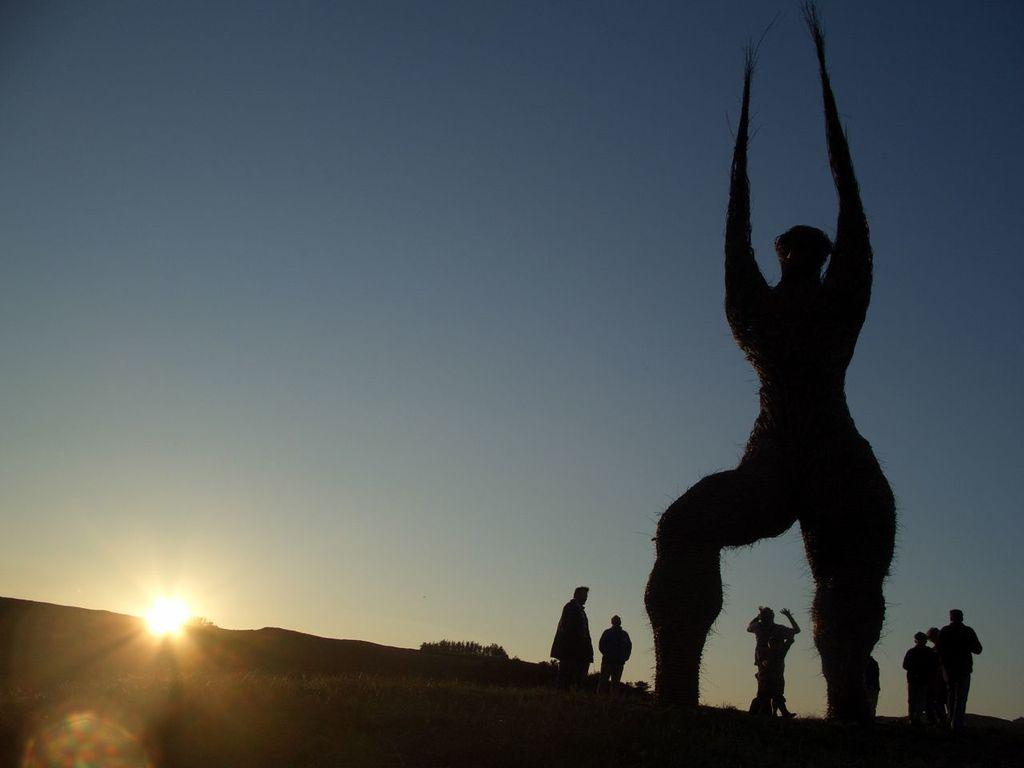How many people are in the image? There are persons standing in the image. What are the persons doing in the image? The persons are staring at statues. What type of honey is being used to clean the statues in the image? There is no honey present in the image, and the statues are not being cleaned. 